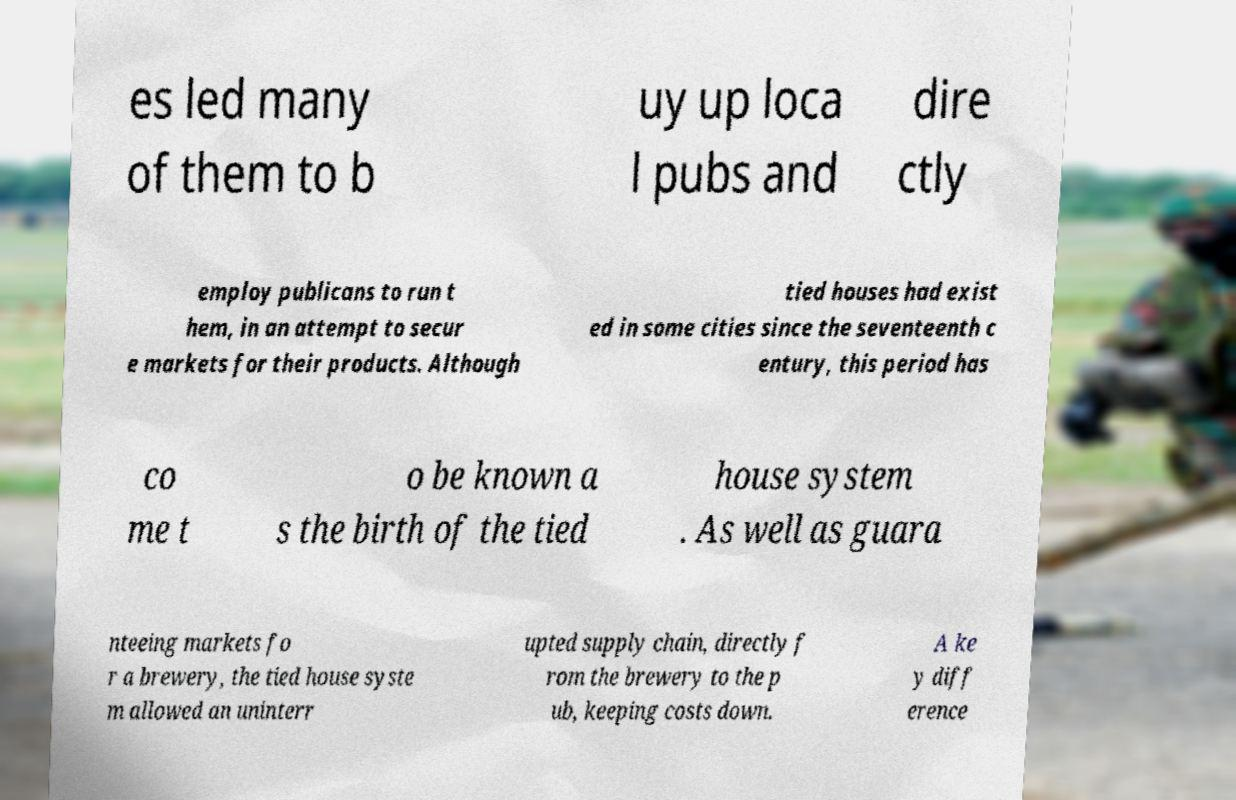There's text embedded in this image that I need extracted. Can you transcribe it verbatim? es led many of them to b uy up loca l pubs and dire ctly employ publicans to run t hem, in an attempt to secur e markets for their products. Although tied houses had exist ed in some cities since the seventeenth c entury, this period has co me t o be known a s the birth of the tied house system . As well as guara nteeing markets fo r a brewery, the tied house syste m allowed an uninterr upted supply chain, directly f rom the brewery to the p ub, keeping costs down. A ke y diff erence 